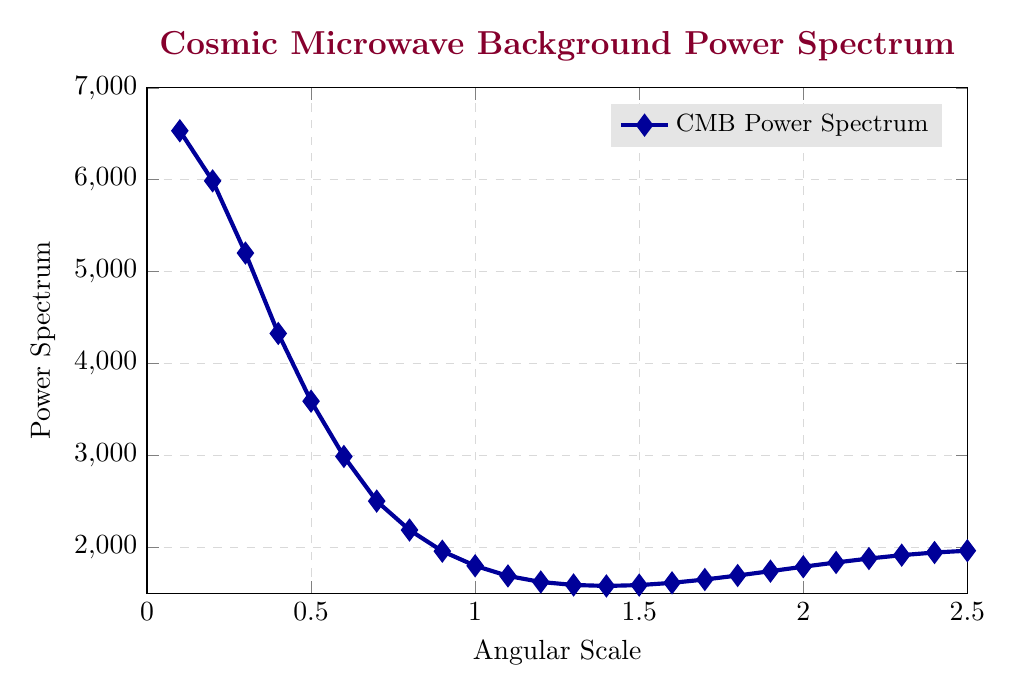What is the value of the power spectrum at an angular scale of 0.5? Locate the angular scale of 0.5 on the x-axis, then find its corresponding value on the y-axis.
Answer: 3589.2 At what angular scale does the power spectrum reach its highest value? Identify the highest point on the y-axis and trace it back to the x-axis to find the angular scale.
Answer: 0.1 How does the power spectrum change from an angular scale of 1.0 to 2.0? Observe and compare the y-axis values for angular scales 1.0 (1798.2) and 2.0 (1787.8). Subtract the latter from the former.
Answer: It decreases by 10.4 What is the average power spectrum value between angular scales 0.1 and 0.5? Sum the values of the power spectra at these scales and divide by the number of points: (6532.4 + 5987.1 + 5201.8 + 4326.5 + 3589.2) / 5 = 5127.4
Answer: 5127.4 Between the angular scales 1.5 and 1.7, what trend is observed in the power spectrum? Compare the values at 1.5 (1587.9), 1.6 (1612.4), and 1.7 (1648.7) to see the pattern. The values are increasing.
Answer: Increasing What can be inferred about the power spectrum variability in the angular scale range 1.2 to 1.5? Analyze the values 1.2 (1621.8), 1.3 (1589.3), 1.4 (1578.6), and 1.5 (1587.9) and see the smaller changes among them.
Answer: Relatively stable with minor fluctuations 